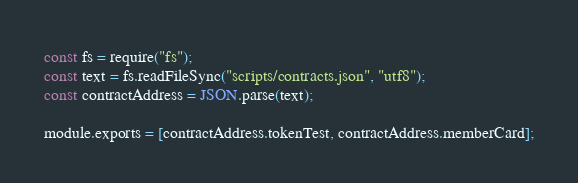Convert code to text. <code><loc_0><loc_0><loc_500><loc_500><_JavaScript_>const fs = require("fs");
const text = fs.readFileSync("scripts/contracts.json", "utf8");
const contractAddress = JSON.parse(text);

module.exports = [contractAddress.tokenTest, contractAddress.memberCard];
</code> 